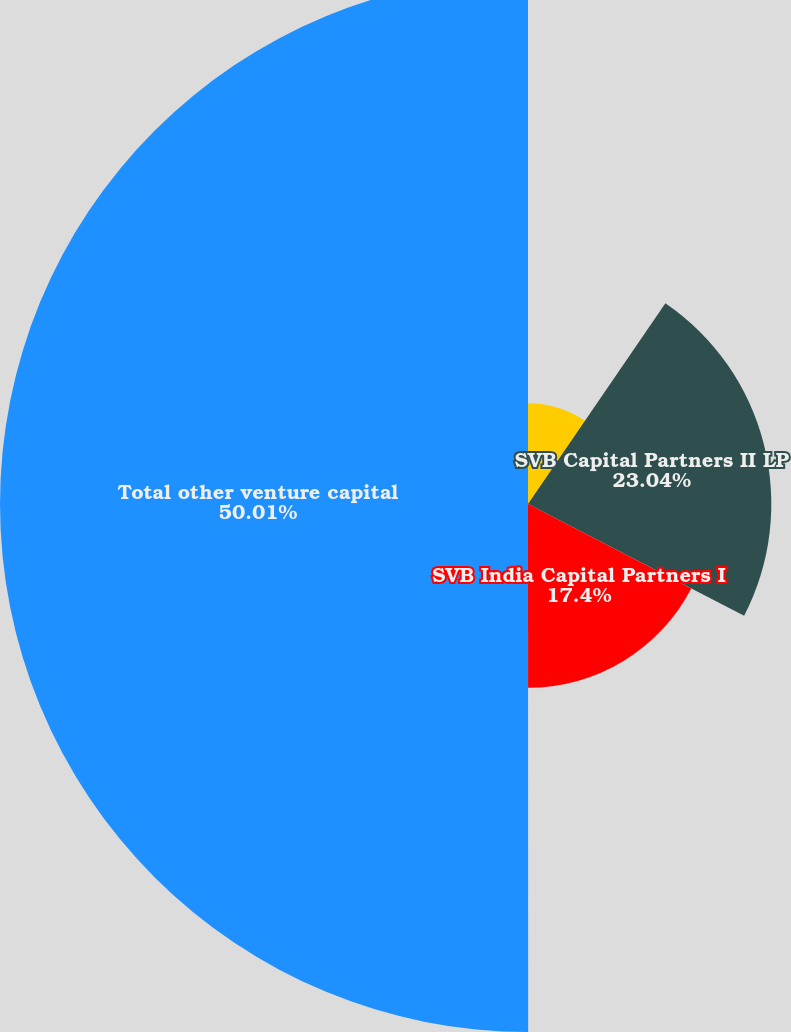<chart> <loc_0><loc_0><loc_500><loc_500><pie_chart><fcel>Silicon Valley BancVentures LP<fcel>SVB Capital Partners II LP<fcel>SVB India Capital Partners I<fcel>Total other venture capital<nl><fcel>9.55%<fcel>23.04%<fcel>17.4%<fcel>50.0%<nl></chart> 